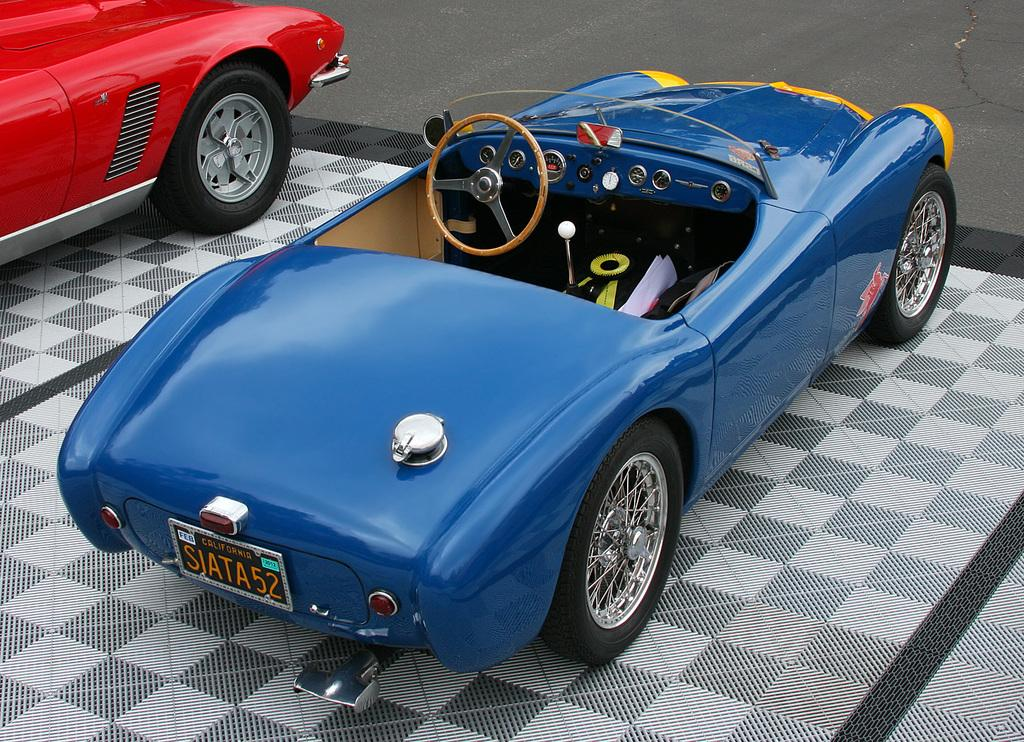What type of vehicles can be seen in the image? There are cars in the image. What is located at the top of the image? There is a wall at the top of the image. What surface is visible in the background of the image? There is a floor visible in the background of the image. What type of wine is being served in the image? There is no wine present in the image. How does the image judge the quality of the cars? The image does not judge the quality of the cars; it simply shows their presence. 